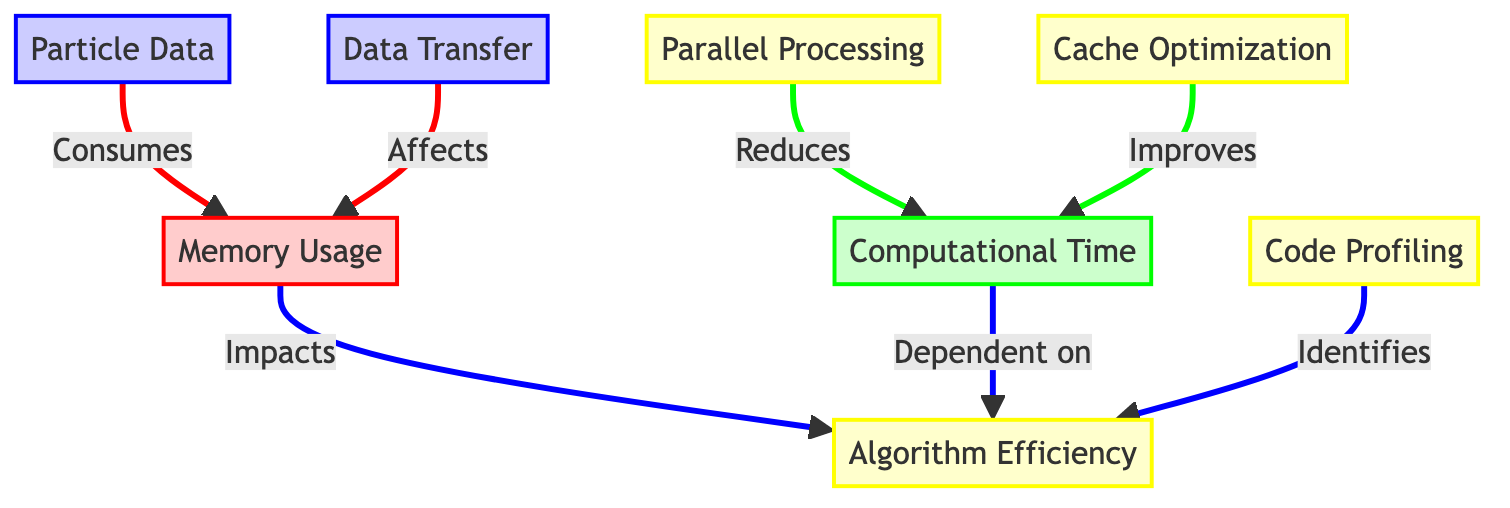What does N3 represent in the diagram? N3 is labeled as "Particle Data" in the diagram, which signifies its role in memory and time consumption.
Answer: Particle Data How many classes are defined in the diagram? The diagram defines four classes: default, memoryClass, computeClass, and optimizeClass.
Answer: Four What effect does N5 have on N2? N5, which stands for "Cache Optimization," improves N2, indicating that it reduces computational time.
Answer: Improves Which node consumes memory according to the diagram? The diagram shows that N3, or "Particle Data," consumes memory, directly linked to N1, which represents "Memory Usage."
Answer: Particle Data What is the relationship between N1 and N7? N1 (Memory Usage) impacts N7 (Algorithm Efficiency), indicating that memory usage influences the efficiency of algorithms in simulations.
Answer: Impacts Explain how N4 affects N2 in this diagram. N4 is "Parallel Processing," which reduces N2, meaning that implementing parallel processing allows for decreased computational time in simulations.
Answer: Reduces Which node directly affects memory usage other than N3? N8, labeled as "Data Transfer," is the other node that affects memory usage according to the connections shown in the diagram.
Answer: Data Transfer What does N6 identify in the context of the diagram? N6, known as "Code Profiling," identifies N7, indicating its role in isolating aspects of algorithm efficiency.
Answer: Identifies How many connections lead into N2 in the diagram? N2 has two incoming connections: one from N4 and one from N5, showing the influences of parallel processing and cache optimization on computational time.
Answer: Two 